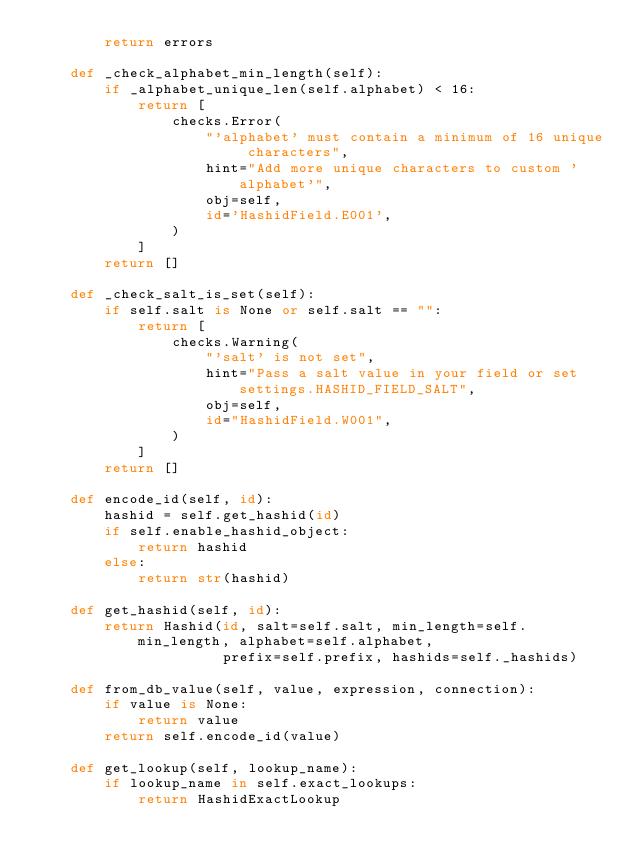<code> <loc_0><loc_0><loc_500><loc_500><_Python_>        return errors

    def _check_alphabet_min_length(self):
        if _alphabet_unique_len(self.alphabet) < 16:
            return [
                checks.Error(
                    "'alphabet' must contain a minimum of 16 unique characters",
                    hint="Add more unique characters to custom 'alphabet'",
                    obj=self,
                    id='HashidField.E001',
                )
            ]
        return []

    def _check_salt_is_set(self):
        if self.salt is None or self.salt == "":
            return [
                checks.Warning(
                    "'salt' is not set",
                    hint="Pass a salt value in your field or set settings.HASHID_FIELD_SALT",
                    obj=self,
                    id="HashidField.W001",
                )
            ]
        return []

    def encode_id(self, id):
        hashid = self.get_hashid(id)
        if self.enable_hashid_object:
            return hashid
        else:
            return str(hashid)

    def get_hashid(self, id):
        return Hashid(id, salt=self.salt, min_length=self.min_length, alphabet=self.alphabet,
                      prefix=self.prefix, hashids=self._hashids)

    def from_db_value(self, value, expression, connection):
        if value is None:
            return value
        return self.encode_id(value)

    def get_lookup(self, lookup_name):
        if lookup_name in self.exact_lookups:
            return HashidExactLookup</code> 